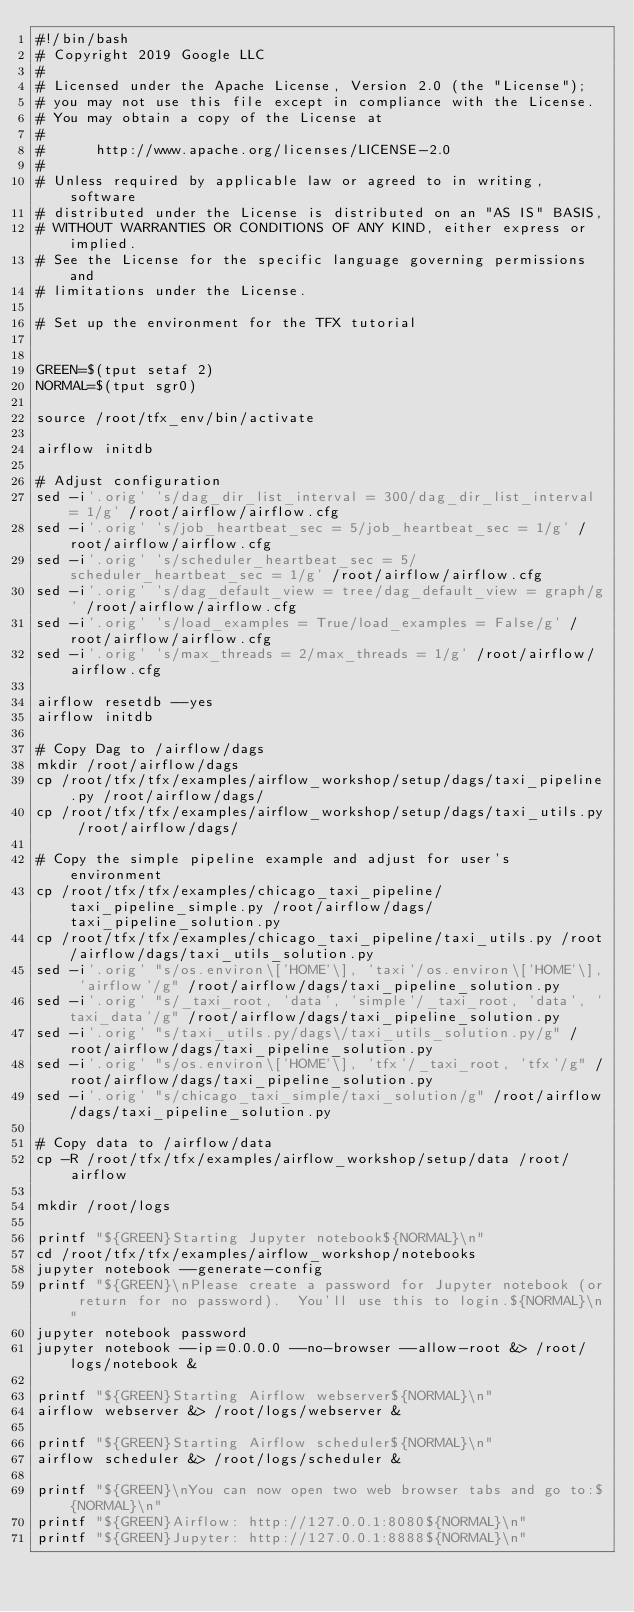<code> <loc_0><loc_0><loc_500><loc_500><_Bash_>#!/bin/bash
# Copyright 2019 Google LLC
#
# Licensed under the Apache License, Version 2.0 (the "License");
# you may not use this file except in compliance with the License.
# You may obtain a copy of the License at
#
#      http://www.apache.org/licenses/LICENSE-2.0
#
# Unless required by applicable law or agreed to in writing, software
# distributed under the License is distributed on an "AS IS" BASIS,
# WITHOUT WARRANTIES OR CONDITIONS OF ANY KIND, either express or implied.
# See the License for the specific language governing permissions and
# limitations under the License.

# Set up the environment for the TFX tutorial


GREEN=$(tput setaf 2)
NORMAL=$(tput sgr0)

source /root/tfx_env/bin/activate

airflow initdb

# Adjust configuration
sed -i'.orig' 's/dag_dir_list_interval = 300/dag_dir_list_interval = 1/g' /root/airflow/airflow.cfg
sed -i'.orig' 's/job_heartbeat_sec = 5/job_heartbeat_sec = 1/g' /root/airflow/airflow.cfg
sed -i'.orig' 's/scheduler_heartbeat_sec = 5/scheduler_heartbeat_sec = 1/g' /root/airflow/airflow.cfg
sed -i'.orig' 's/dag_default_view = tree/dag_default_view = graph/g' /root/airflow/airflow.cfg
sed -i'.orig' 's/load_examples = True/load_examples = False/g' /root/airflow/airflow.cfg
sed -i'.orig' 's/max_threads = 2/max_threads = 1/g' /root/airflow/airflow.cfg

airflow resetdb --yes
airflow initdb

# Copy Dag to /airflow/dags
mkdir /root/airflow/dags
cp /root/tfx/tfx/examples/airflow_workshop/setup/dags/taxi_pipeline.py /root/airflow/dags/
cp /root/tfx/tfx/examples/airflow_workshop/setup/dags/taxi_utils.py /root/airflow/dags/

# Copy the simple pipeline example and adjust for user's environment
cp /root/tfx/tfx/examples/chicago_taxi_pipeline/taxi_pipeline_simple.py /root/airflow/dags/taxi_pipeline_solution.py
cp /root/tfx/tfx/examples/chicago_taxi_pipeline/taxi_utils.py /root/airflow/dags/taxi_utils_solution.py
sed -i'.orig' "s/os.environ\['HOME'\], 'taxi'/os.environ\['HOME'\], 'airflow'/g" /root/airflow/dags/taxi_pipeline_solution.py
sed -i'.orig' "s/_taxi_root, 'data', 'simple'/_taxi_root, 'data', 'taxi_data'/g" /root/airflow/dags/taxi_pipeline_solution.py
sed -i'.orig' "s/taxi_utils.py/dags\/taxi_utils_solution.py/g" /root/airflow/dags/taxi_pipeline_solution.py
sed -i'.orig' "s/os.environ\['HOME'\], 'tfx'/_taxi_root, 'tfx'/g" /root/airflow/dags/taxi_pipeline_solution.py
sed -i'.orig' "s/chicago_taxi_simple/taxi_solution/g" /root/airflow/dags/taxi_pipeline_solution.py

# Copy data to /airflow/data
cp -R /root/tfx/tfx/examples/airflow_workshop/setup/data /root/airflow

mkdir /root/logs

printf "${GREEN}Starting Jupyter notebook${NORMAL}\n"
cd /root/tfx/tfx/examples/airflow_workshop/notebooks
jupyter notebook --generate-config
printf "${GREEN}\nPlease create a password for Jupyter notebook (or return for no password).  You'll use this to login.${NORMAL}\n"
jupyter notebook password
jupyter notebook --ip=0.0.0.0 --no-browser --allow-root &> /root/logs/notebook &

printf "${GREEN}Starting Airflow webserver${NORMAL}\n"
airflow webserver &> /root/logs/webserver &

printf "${GREEN}Starting Airflow scheduler${NORMAL}\n"
airflow scheduler &> /root/logs/scheduler &

printf "${GREEN}\nYou can now open two web browser tabs and go to:${NORMAL}\n"
printf "${GREEN}Airflow: http://127.0.0.1:8080${NORMAL}\n"
printf "${GREEN}Jupyter: http://127.0.0.1:8888${NORMAL}\n"
</code> 